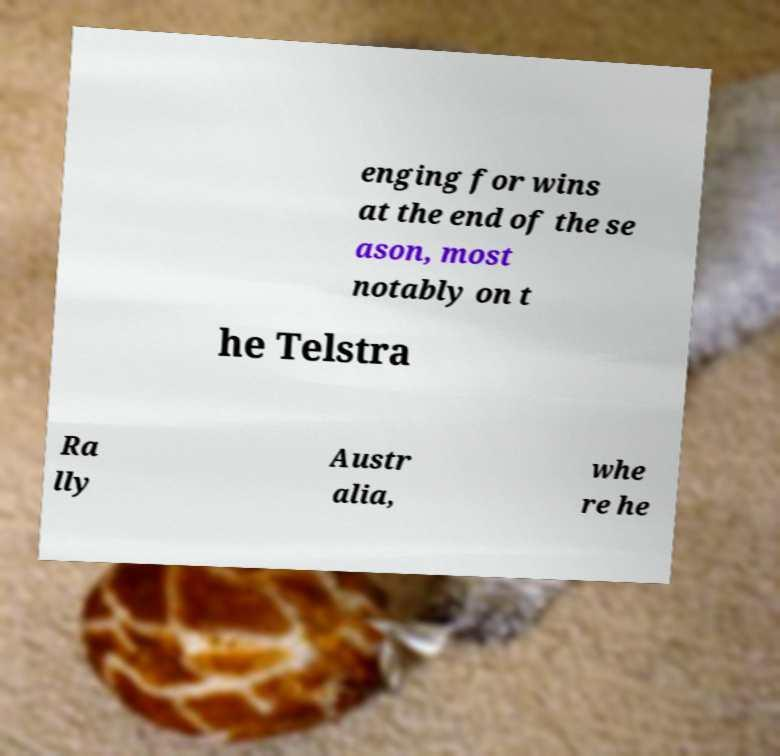For documentation purposes, I need the text within this image transcribed. Could you provide that? enging for wins at the end of the se ason, most notably on t he Telstra Ra lly Austr alia, whe re he 